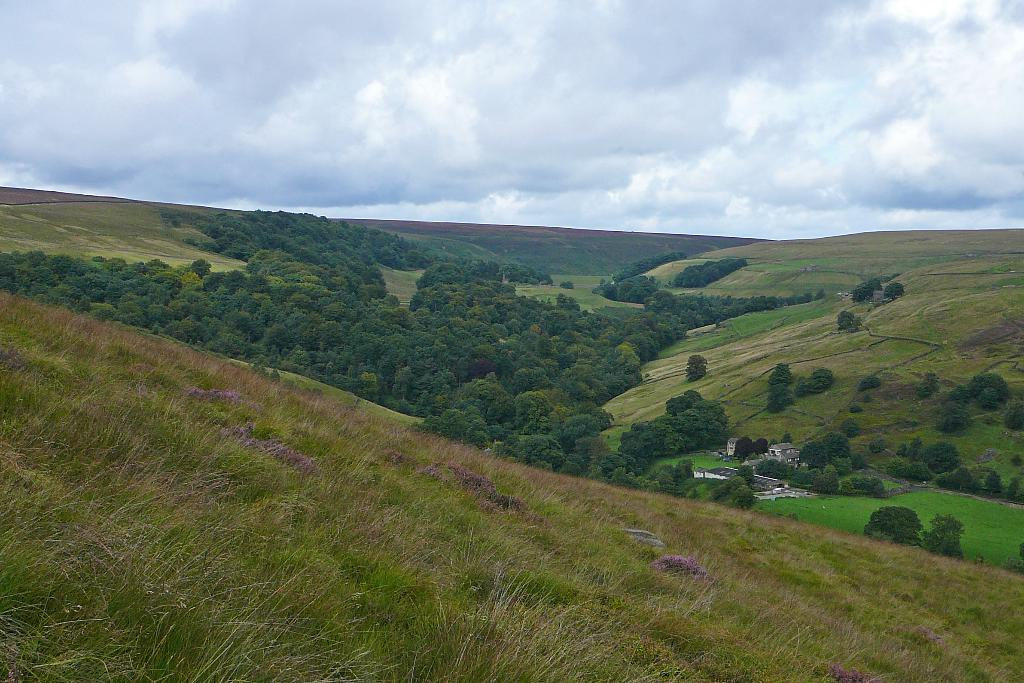What type of ground surface is visible in the image? There is grass on the ground in the image. What type of vegetation can be seen in the image? There are trees in the image. What else is present in the image besides grass and trees? There are other objects in the image. What is the condition of the sky in the image? The sky is cloudy in the image. What type of pin can be seen holding the invention together in the image? There is no pin or invention present in the image; it features grass, trees, and other objects. 